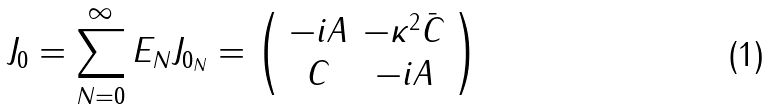Convert formula to latex. <formula><loc_0><loc_0><loc_500><loc_500>J _ { 0 } = \sum _ { N = 0 } ^ { \infty } E _ { N } J _ { 0 _ { N } } = \left ( \begin{array} { c c } - i A & - \kappa ^ { 2 } \bar { C } \\ C & - i A \end{array} \right )</formula> 